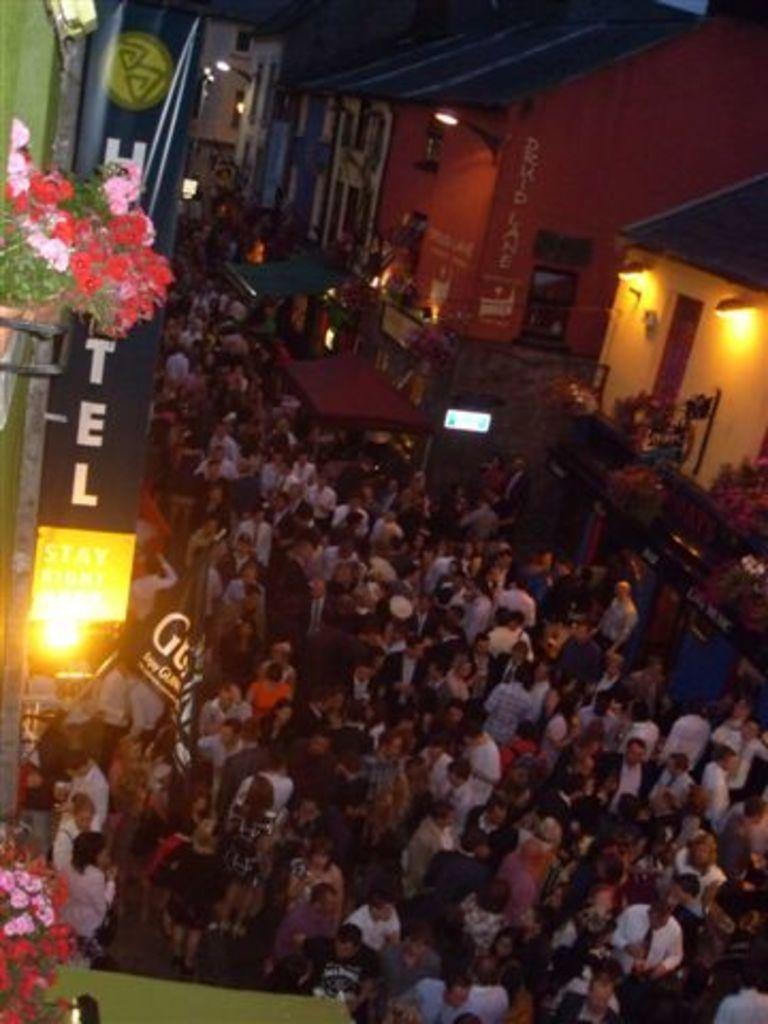Could you give a brief overview of what you see in this image? Here people are standing, these are buildings, this is light and plant. 